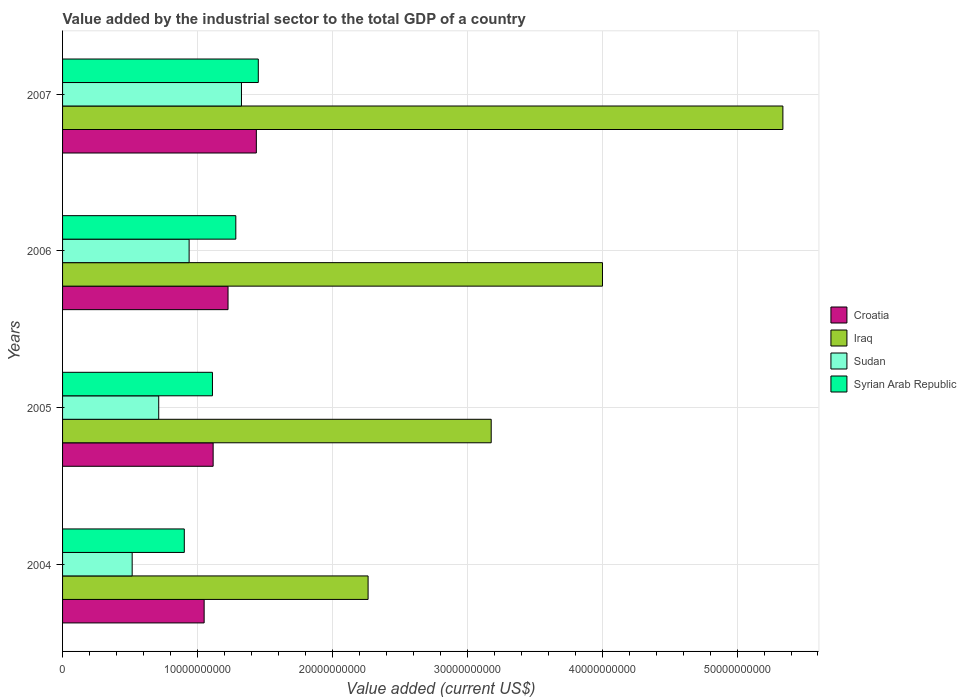How many groups of bars are there?
Ensure brevity in your answer.  4. Are the number of bars per tick equal to the number of legend labels?
Your answer should be very brief. Yes. In how many cases, is the number of bars for a given year not equal to the number of legend labels?
Your answer should be compact. 0. What is the value added by the industrial sector to the total GDP in Iraq in 2005?
Keep it short and to the point. 3.18e+1. Across all years, what is the maximum value added by the industrial sector to the total GDP in Iraq?
Your response must be concise. 5.34e+1. Across all years, what is the minimum value added by the industrial sector to the total GDP in Syrian Arab Republic?
Provide a short and direct response. 9.02e+09. In which year was the value added by the industrial sector to the total GDP in Iraq maximum?
Provide a succinct answer. 2007. What is the total value added by the industrial sector to the total GDP in Croatia in the graph?
Keep it short and to the point. 4.83e+1. What is the difference between the value added by the industrial sector to the total GDP in Syrian Arab Republic in 2004 and that in 2006?
Your response must be concise. -3.82e+09. What is the difference between the value added by the industrial sector to the total GDP in Sudan in 2004 and the value added by the industrial sector to the total GDP in Croatia in 2007?
Ensure brevity in your answer.  -9.21e+09. What is the average value added by the industrial sector to the total GDP in Sudan per year?
Keep it short and to the point. 8.73e+09. In the year 2005, what is the difference between the value added by the industrial sector to the total GDP in Iraq and value added by the industrial sector to the total GDP in Sudan?
Provide a short and direct response. 2.46e+1. In how many years, is the value added by the industrial sector to the total GDP in Iraq greater than 6000000000 US$?
Provide a short and direct response. 4. What is the ratio of the value added by the industrial sector to the total GDP in Syrian Arab Republic in 2004 to that in 2005?
Your answer should be compact. 0.81. Is the difference between the value added by the industrial sector to the total GDP in Iraq in 2005 and 2007 greater than the difference between the value added by the industrial sector to the total GDP in Sudan in 2005 and 2007?
Offer a very short reply. No. What is the difference between the highest and the second highest value added by the industrial sector to the total GDP in Sudan?
Your answer should be very brief. 3.88e+09. What is the difference between the highest and the lowest value added by the industrial sector to the total GDP in Syrian Arab Republic?
Give a very brief answer. 5.49e+09. Is the sum of the value added by the industrial sector to the total GDP in Iraq in 2004 and 2006 greater than the maximum value added by the industrial sector to the total GDP in Croatia across all years?
Offer a terse response. Yes. What does the 1st bar from the top in 2006 represents?
Give a very brief answer. Syrian Arab Republic. What does the 1st bar from the bottom in 2005 represents?
Your response must be concise. Croatia. Does the graph contain grids?
Give a very brief answer. Yes. How many legend labels are there?
Your answer should be compact. 4. What is the title of the graph?
Provide a short and direct response. Value added by the industrial sector to the total GDP of a country. What is the label or title of the X-axis?
Offer a very short reply. Value added (current US$). What is the label or title of the Y-axis?
Offer a very short reply. Years. What is the Value added (current US$) of Croatia in 2004?
Provide a short and direct response. 1.05e+1. What is the Value added (current US$) of Iraq in 2004?
Your answer should be very brief. 2.26e+1. What is the Value added (current US$) of Sudan in 2004?
Ensure brevity in your answer.  5.16e+09. What is the Value added (current US$) in Syrian Arab Republic in 2004?
Keep it short and to the point. 9.02e+09. What is the Value added (current US$) in Croatia in 2005?
Offer a very short reply. 1.12e+1. What is the Value added (current US$) of Iraq in 2005?
Keep it short and to the point. 3.18e+1. What is the Value added (current US$) in Sudan in 2005?
Your response must be concise. 7.13e+09. What is the Value added (current US$) in Syrian Arab Republic in 2005?
Your answer should be compact. 1.11e+1. What is the Value added (current US$) in Croatia in 2006?
Offer a terse response. 1.23e+1. What is the Value added (current US$) of Iraq in 2006?
Offer a terse response. 4.00e+1. What is the Value added (current US$) in Sudan in 2006?
Your answer should be compact. 9.38e+09. What is the Value added (current US$) of Syrian Arab Republic in 2006?
Provide a succinct answer. 1.28e+1. What is the Value added (current US$) of Croatia in 2007?
Give a very brief answer. 1.44e+1. What is the Value added (current US$) of Iraq in 2007?
Provide a succinct answer. 5.34e+1. What is the Value added (current US$) of Sudan in 2007?
Keep it short and to the point. 1.33e+1. What is the Value added (current US$) in Syrian Arab Republic in 2007?
Your answer should be very brief. 1.45e+1. Across all years, what is the maximum Value added (current US$) of Croatia?
Offer a very short reply. 1.44e+1. Across all years, what is the maximum Value added (current US$) of Iraq?
Offer a very short reply. 5.34e+1. Across all years, what is the maximum Value added (current US$) in Sudan?
Provide a succinct answer. 1.33e+1. Across all years, what is the maximum Value added (current US$) in Syrian Arab Republic?
Your response must be concise. 1.45e+1. Across all years, what is the minimum Value added (current US$) of Croatia?
Your answer should be compact. 1.05e+1. Across all years, what is the minimum Value added (current US$) in Iraq?
Your answer should be compact. 2.26e+1. Across all years, what is the minimum Value added (current US$) of Sudan?
Offer a terse response. 5.16e+09. Across all years, what is the minimum Value added (current US$) in Syrian Arab Republic?
Offer a very short reply. 9.02e+09. What is the total Value added (current US$) in Croatia in the graph?
Keep it short and to the point. 4.83e+1. What is the total Value added (current US$) of Iraq in the graph?
Give a very brief answer. 1.48e+11. What is the total Value added (current US$) in Sudan in the graph?
Offer a terse response. 3.49e+1. What is the total Value added (current US$) of Syrian Arab Republic in the graph?
Offer a terse response. 4.75e+1. What is the difference between the Value added (current US$) of Croatia in 2004 and that in 2005?
Your response must be concise. -6.68e+08. What is the difference between the Value added (current US$) in Iraq in 2004 and that in 2005?
Your response must be concise. -9.13e+09. What is the difference between the Value added (current US$) in Sudan in 2004 and that in 2005?
Provide a short and direct response. -1.97e+09. What is the difference between the Value added (current US$) in Syrian Arab Republic in 2004 and that in 2005?
Give a very brief answer. -2.09e+09. What is the difference between the Value added (current US$) of Croatia in 2004 and that in 2006?
Ensure brevity in your answer.  -1.77e+09. What is the difference between the Value added (current US$) in Iraq in 2004 and that in 2006?
Your answer should be compact. -1.74e+1. What is the difference between the Value added (current US$) of Sudan in 2004 and that in 2006?
Make the answer very short. -4.22e+09. What is the difference between the Value added (current US$) of Syrian Arab Republic in 2004 and that in 2006?
Make the answer very short. -3.82e+09. What is the difference between the Value added (current US$) of Croatia in 2004 and that in 2007?
Your answer should be compact. -3.87e+09. What is the difference between the Value added (current US$) in Iraq in 2004 and that in 2007?
Offer a terse response. -3.08e+1. What is the difference between the Value added (current US$) in Sudan in 2004 and that in 2007?
Your answer should be very brief. -8.10e+09. What is the difference between the Value added (current US$) in Syrian Arab Republic in 2004 and that in 2007?
Make the answer very short. -5.49e+09. What is the difference between the Value added (current US$) of Croatia in 2005 and that in 2006?
Make the answer very short. -1.10e+09. What is the difference between the Value added (current US$) of Iraq in 2005 and that in 2006?
Give a very brief answer. -8.25e+09. What is the difference between the Value added (current US$) of Sudan in 2005 and that in 2006?
Your answer should be compact. -2.25e+09. What is the difference between the Value added (current US$) of Syrian Arab Republic in 2005 and that in 2006?
Ensure brevity in your answer.  -1.73e+09. What is the difference between the Value added (current US$) of Croatia in 2005 and that in 2007?
Provide a short and direct response. -3.20e+09. What is the difference between the Value added (current US$) of Iraq in 2005 and that in 2007?
Your answer should be very brief. -2.16e+1. What is the difference between the Value added (current US$) of Sudan in 2005 and that in 2007?
Your response must be concise. -6.13e+09. What is the difference between the Value added (current US$) in Syrian Arab Republic in 2005 and that in 2007?
Your answer should be compact. -3.40e+09. What is the difference between the Value added (current US$) in Croatia in 2006 and that in 2007?
Provide a short and direct response. -2.10e+09. What is the difference between the Value added (current US$) of Iraq in 2006 and that in 2007?
Provide a succinct answer. -1.34e+1. What is the difference between the Value added (current US$) of Sudan in 2006 and that in 2007?
Your answer should be very brief. -3.88e+09. What is the difference between the Value added (current US$) of Syrian Arab Republic in 2006 and that in 2007?
Provide a short and direct response. -1.67e+09. What is the difference between the Value added (current US$) in Croatia in 2004 and the Value added (current US$) in Iraq in 2005?
Your answer should be very brief. -2.13e+1. What is the difference between the Value added (current US$) of Croatia in 2004 and the Value added (current US$) of Sudan in 2005?
Provide a succinct answer. 3.37e+09. What is the difference between the Value added (current US$) of Croatia in 2004 and the Value added (current US$) of Syrian Arab Republic in 2005?
Your response must be concise. -6.17e+08. What is the difference between the Value added (current US$) in Iraq in 2004 and the Value added (current US$) in Sudan in 2005?
Offer a terse response. 1.55e+1. What is the difference between the Value added (current US$) in Iraq in 2004 and the Value added (current US$) in Syrian Arab Republic in 2005?
Offer a very short reply. 1.15e+1. What is the difference between the Value added (current US$) in Sudan in 2004 and the Value added (current US$) in Syrian Arab Republic in 2005?
Keep it short and to the point. -5.95e+09. What is the difference between the Value added (current US$) in Croatia in 2004 and the Value added (current US$) in Iraq in 2006?
Give a very brief answer. -2.95e+1. What is the difference between the Value added (current US$) of Croatia in 2004 and the Value added (current US$) of Sudan in 2006?
Give a very brief answer. 1.11e+09. What is the difference between the Value added (current US$) of Croatia in 2004 and the Value added (current US$) of Syrian Arab Republic in 2006?
Your response must be concise. -2.35e+09. What is the difference between the Value added (current US$) of Iraq in 2004 and the Value added (current US$) of Sudan in 2006?
Keep it short and to the point. 1.33e+1. What is the difference between the Value added (current US$) in Iraq in 2004 and the Value added (current US$) in Syrian Arab Republic in 2006?
Provide a succinct answer. 9.81e+09. What is the difference between the Value added (current US$) in Sudan in 2004 and the Value added (current US$) in Syrian Arab Republic in 2006?
Make the answer very short. -7.68e+09. What is the difference between the Value added (current US$) of Croatia in 2004 and the Value added (current US$) of Iraq in 2007?
Your answer should be very brief. -4.29e+1. What is the difference between the Value added (current US$) of Croatia in 2004 and the Value added (current US$) of Sudan in 2007?
Offer a very short reply. -2.77e+09. What is the difference between the Value added (current US$) in Croatia in 2004 and the Value added (current US$) in Syrian Arab Republic in 2007?
Your answer should be very brief. -4.02e+09. What is the difference between the Value added (current US$) of Iraq in 2004 and the Value added (current US$) of Sudan in 2007?
Offer a very short reply. 9.39e+09. What is the difference between the Value added (current US$) of Iraq in 2004 and the Value added (current US$) of Syrian Arab Republic in 2007?
Offer a terse response. 8.14e+09. What is the difference between the Value added (current US$) of Sudan in 2004 and the Value added (current US$) of Syrian Arab Republic in 2007?
Make the answer very short. -9.35e+09. What is the difference between the Value added (current US$) of Croatia in 2005 and the Value added (current US$) of Iraq in 2006?
Ensure brevity in your answer.  -2.89e+1. What is the difference between the Value added (current US$) in Croatia in 2005 and the Value added (current US$) in Sudan in 2006?
Your answer should be very brief. 1.78e+09. What is the difference between the Value added (current US$) of Croatia in 2005 and the Value added (current US$) of Syrian Arab Republic in 2006?
Your response must be concise. -1.68e+09. What is the difference between the Value added (current US$) of Iraq in 2005 and the Value added (current US$) of Sudan in 2006?
Ensure brevity in your answer.  2.24e+1. What is the difference between the Value added (current US$) of Iraq in 2005 and the Value added (current US$) of Syrian Arab Republic in 2006?
Your answer should be very brief. 1.89e+1. What is the difference between the Value added (current US$) in Sudan in 2005 and the Value added (current US$) in Syrian Arab Republic in 2006?
Offer a terse response. -5.71e+09. What is the difference between the Value added (current US$) in Croatia in 2005 and the Value added (current US$) in Iraq in 2007?
Your answer should be compact. -4.22e+1. What is the difference between the Value added (current US$) in Croatia in 2005 and the Value added (current US$) in Sudan in 2007?
Your response must be concise. -2.10e+09. What is the difference between the Value added (current US$) in Croatia in 2005 and the Value added (current US$) in Syrian Arab Republic in 2007?
Your answer should be very brief. -3.35e+09. What is the difference between the Value added (current US$) of Iraq in 2005 and the Value added (current US$) of Sudan in 2007?
Ensure brevity in your answer.  1.85e+1. What is the difference between the Value added (current US$) in Iraq in 2005 and the Value added (current US$) in Syrian Arab Republic in 2007?
Your answer should be compact. 1.73e+1. What is the difference between the Value added (current US$) in Sudan in 2005 and the Value added (current US$) in Syrian Arab Republic in 2007?
Keep it short and to the point. -7.38e+09. What is the difference between the Value added (current US$) in Croatia in 2006 and the Value added (current US$) in Iraq in 2007?
Your answer should be compact. -4.11e+1. What is the difference between the Value added (current US$) of Croatia in 2006 and the Value added (current US$) of Sudan in 2007?
Provide a short and direct response. -9.96e+08. What is the difference between the Value added (current US$) in Croatia in 2006 and the Value added (current US$) in Syrian Arab Republic in 2007?
Keep it short and to the point. -2.24e+09. What is the difference between the Value added (current US$) of Iraq in 2006 and the Value added (current US$) of Sudan in 2007?
Offer a very short reply. 2.68e+1. What is the difference between the Value added (current US$) in Iraq in 2006 and the Value added (current US$) in Syrian Arab Republic in 2007?
Offer a terse response. 2.55e+1. What is the difference between the Value added (current US$) in Sudan in 2006 and the Value added (current US$) in Syrian Arab Republic in 2007?
Provide a short and direct response. -5.13e+09. What is the average Value added (current US$) of Croatia per year?
Keep it short and to the point. 1.21e+1. What is the average Value added (current US$) of Iraq per year?
Provide a succinct answer. 3.70e+1. What is the average Value added (current US$) in Sudan per year?
Provide a succinct answer. 8.73e+09. What is the average Value added (current US$) of Syrian Arab Republic per year?
Keep it short and to the point. 1.19e+1. In the year 2004, what is the difference between the Value added (current US$) in Croatia and Value added (current US$) in Iraq?
Your answer should be compact. -1.22e+1. In the year 2004, what is the difference between the Value added (current US$) in Croatia and Value added (current US$) in Sudan?
Offer a terse response. 5.33e+09. In the year 2004, what is the difference between the Value added (current US$) in Croatia and Value added (current US$) in Syrian Arab Republic?
Give a very brief answer. 1.47e+09. In the year 2004, what is the difference between the Value added (current US$) of Iraq and Value added (current US$) of Sudan?
Provide a short and direct response. 1.75e+1. In the year 2004, what is the difference between the Value added (current US$) of Iraq and Value added (current US$) of Syrian Arab Republic?
Provide a succinct answer. 1.36e+1. In the year 2004, what is the difference between the Value added (current US$) in Sudan and Value added (current US$) in Syrian Arab Republic?
Provide a succinct answer. -3.86e+09. In the year 2005, what is the difference between the Value added (current US$) in Croatia and Value added (current US$) in Iraq?
Provide a succinct answer. -2.06e+1. In the year 2005, what is the difference between the Value added (current US$) of Croatia and Value added (current US$) of Sudan?
Offer a terse response. 4.03e+09. In the year 2005, what is the difference between the Value added (current US$) of Croatia and Value added (current US$) of Syrian Arab Republic?
Give a very brief answer. 5.09e+07. In the year 2005, what is the difference between the Value added (current US$) of Iraq and Value added (current US$) of Sudan?
Your answer should be compact. 2.46e+1. In the year 2005, what is the difference between the Value added (current US$) of Iraq and Value added (current US$) of Syrian Arab Republic?
Offer a terse response. 2.07e+1. In the year 2005, what is the difference between the Value added (current US$) of Sudan and Value added (current US$) of Syrian Arab Republic?
Give a very brief answer. -3.98e+09. In the year 2006, what is the difference between the Value added (current US$) in Croatia and Value added (current US$) in Iraq?
Provide a succinct answer. -2.78e+1. In the year 2006, what is the difference between the Value added (current US$) of Croatia and Value added (current US$) of Sudan?
Your answer should be very brief. 2.88e+09. In the year 2006, what is the difference between the Value added (current US$) in Croatia and Value added (current US$) in Syrian Arab Republic?
Give a very brief answer. -5.76e+08. In the year 2006, what is the difference between the Value added (current US$) in Iraq and Value added (current US$) in Sudan?
Provide a succinct answer. 3.06e+1. In the year 2006, what is the difference between the Value added (current US$) in Iraq and Value added (current US$) in Syrian Arab Republic?
Ensure brevity in your answer.  2.72e+1. In the year 2006, what is the difference between the Value added (current US$) in Sudan and Value added (current US$) in Syrian Arab Republic?
Your response must be concise. -3.46e+09. In the year 2007, what is the difference between the Value added (current US$) in Croatia and Value added (current US$) in Iraq?
Ensure brevity in your answer.  -3.90e+1. In the year 2007, what is the difference between the Value added (current US$) of Croatia and Value added (current US$) of Sudan?
Your response must be concise. 1.10e+09. In the year 2007, what is the difference between the Value added (current US$) in Croatia and Value added (current US$) in Syrian Arab Republic?
Keep it short and to the point. -1.45e+08. In the year 2007, what is the difference between the Value added (current US$) of Iraq and Value added (current US$) of Sudan?
Provide a short and direct response. 4.01e+1. In the year 2007, what is the difference between the Value added (current US$) of Iraq and Value added (current US$) of Syrian Arab Republic?
Your answer should be compact. 3.89e+1. In the year 2007, what is the difference between the Value added (current US$) of Sudan and Value added (current US$) of Syrian Arab Republic?
Offer a terse response. -1.25e+09. What is the ratio of the Value added (current US$) in Croatia in 2004 to that in 2005?
Your answer should be compact. 0.94. What is the ratio of the Value added (current US$) of Iraq in 2004 to that in 2005?
Your answer should be very brief. 0.71. What is the ratio of the Value added (current US$) in Sudan in 2004 to that in 2005?
Make the answer very short. 0.72. What is the ratio of the Value added (current US$) of Syrian Arab Republic in 2004 to that in 2005?
Ensure brevity in your answer.  0.81. What is the ratio of the Value added (current US$) in Croatia in 2004 to that in 2006?
Offer a terse response. 0.86. What is the ratio of the Value added (current US$) in Iraq in 2004 to that in 2006?
Your answer should be very brief. 0.57. What is the ratio of the Value added (current US$) of Sudan in 2004 to that in 2006?
Your answer should be very brief. 0.55. What is the ratio of the Value added (current US$) of Syrian Arab Republic in 2004 to that in 2006?
Offer a terse response. 0.7. What is the ratio of the Value added (current US$) in Croatia in 2004 to that in 2007?
Make the answer very short. 0.73. What is the ratio of the Value added (current US$) in Iraq in 2004 to that in 2007?
Provide a succinct answer. 0.42. What is the ratio of the Value added (current US$) in Sudan in 2004 to that in 2007?
Offer a terse response. 0.39. What is the ratio of the Value added (current US$) of Syrian Arab Republic in 2004 to that in 2007?
Your response must be concise. 0.62. What is the ratio of the Value added (current US$) in Croatia in 2005 to that in 2006?
Your answer should be compact. 0.91. What is the ratio of the Value added (current US$) of Iraq in 2005 to that in 2006?
Offer a very short reply. 0.79. What is the ratio of the Value added (current US$) of Sudan in 2005 to that in 2006?
Offer a terse response. 0.76. What is the ratio of the Value added (current US$) in Syrian Arab Republic in 2005 to that in 2006?
Offer a terse response. 0.87. What is the ratio of the Value added (current US$) of Croatia in 2005 to that in 2007?
Your answer should be very brief. 0.78. What is the ratio of the Value added (current US$) of Iraq in 2005 to that in 2007?
Provide a succinct answer. 0.6. What is the ratio of the Value added (current US$) of Sudan in 2005 to that in 2007?
Offer a very short reply. 0.54. What is the ratio of the Value added (current US$) of Syrian Arab Republic in 2005 to that in 2007?
Provide a succinct answer. 0.77. What is the ratio of the Value added (current US$) in Croatia in 2006 to that in 2007?
Make the answer very short. 0.85. What is the ratio of the Value added (current US$) of Iraq in 2006 to that in 2007?
Provide a short and direct response. 0.75. What is the ratio of the Value added (current US$) of Sudan in 2006 to that in 2007?
Provide a short and direct response. 0.71. What is the ratio of the Value added (current US$) in Syrian Arab Republic in 2006 to that in 2007?
Offer a very short reply. 0.89. What is the difference between the highest and the second highest Value added (current US$) of Croatia?
Your answer should be compact. 2.10e+09. What is the difference between the highest and the second highest Value added (current US$) of Iraq?
Make the answer very short. 1.34e+1. What is the difference between the highest and the second highest Value added (current US$) in Sudan?
Make the answer very short. 3.88e+09. What is the difference between the highest and the second highest Value added (current US$) of Syrian Arab Republic?
Provide a short and direct response. 1.67e+09. What is the difference between the highest and the lowest Value added (current US$) of Croatia?
Offer a terse response. 3.87e+09. What is the difference between the highest and the lowest Value added (current US$) of Iraq?
Provide a succinct answer. 3.08e+1. What is the difference between the highest and the lowest Value added (current US$) in Sudan?
Your answer should be compact. 8.10e+09. What is the difference between the highest and the lowest Value added (current US$) in Syrian Arab Republic?
Offer a very short reply. 5.49e+09. 